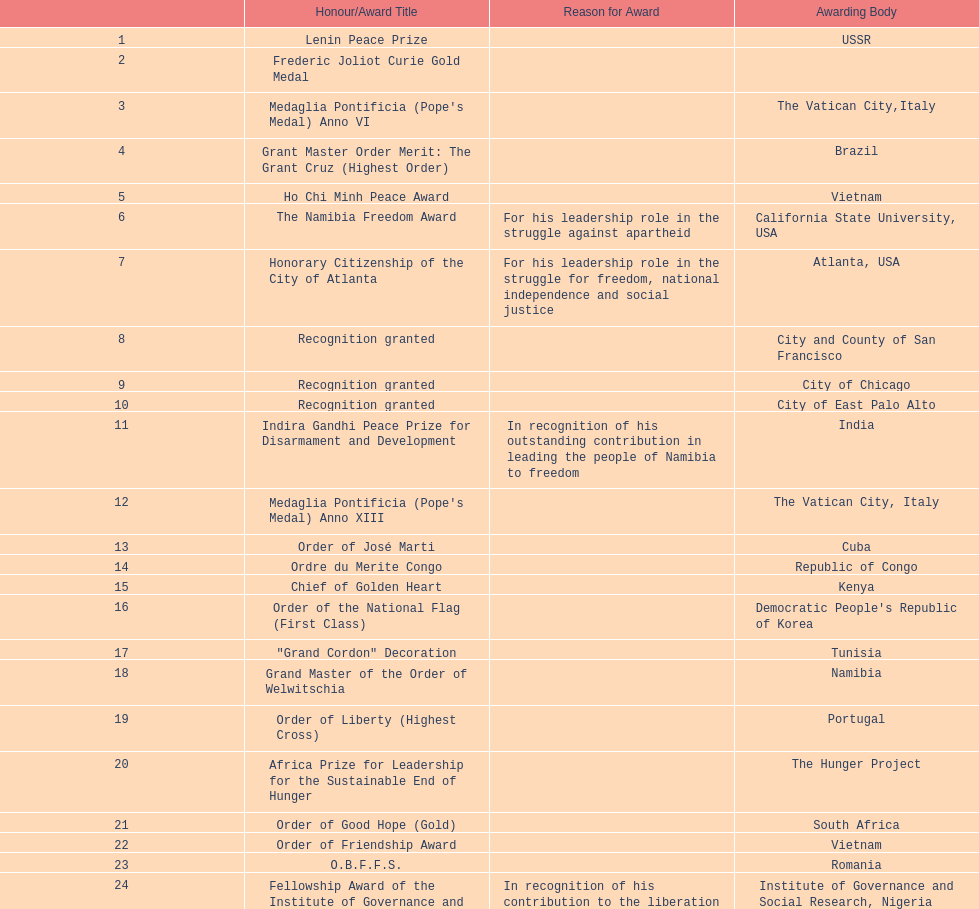After receiving the international kim il sung prize certificate, what was the name of the award/honor bestowed? Sir Seretse Khama SADC Meda. 